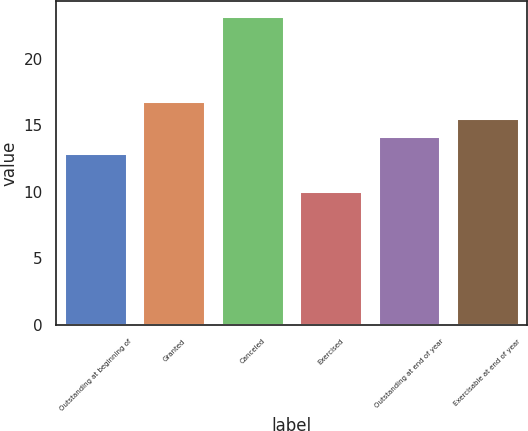Convert chart to OTSL. <chart><loc_0><loc_0><loc_500><loc_500><bar_chart><fcel>Outstanding at beginning of<fcel>Granted<fcel>Canceled<fcel>Exercised<fcel>Outstanding at end of year<fcel>Exercisable at end of year<nl><fcel>12.92<fcel>16.85<fcel>23.2<fcel>10.08<fcel>14.23<fcel>15.54<nl></chart> 